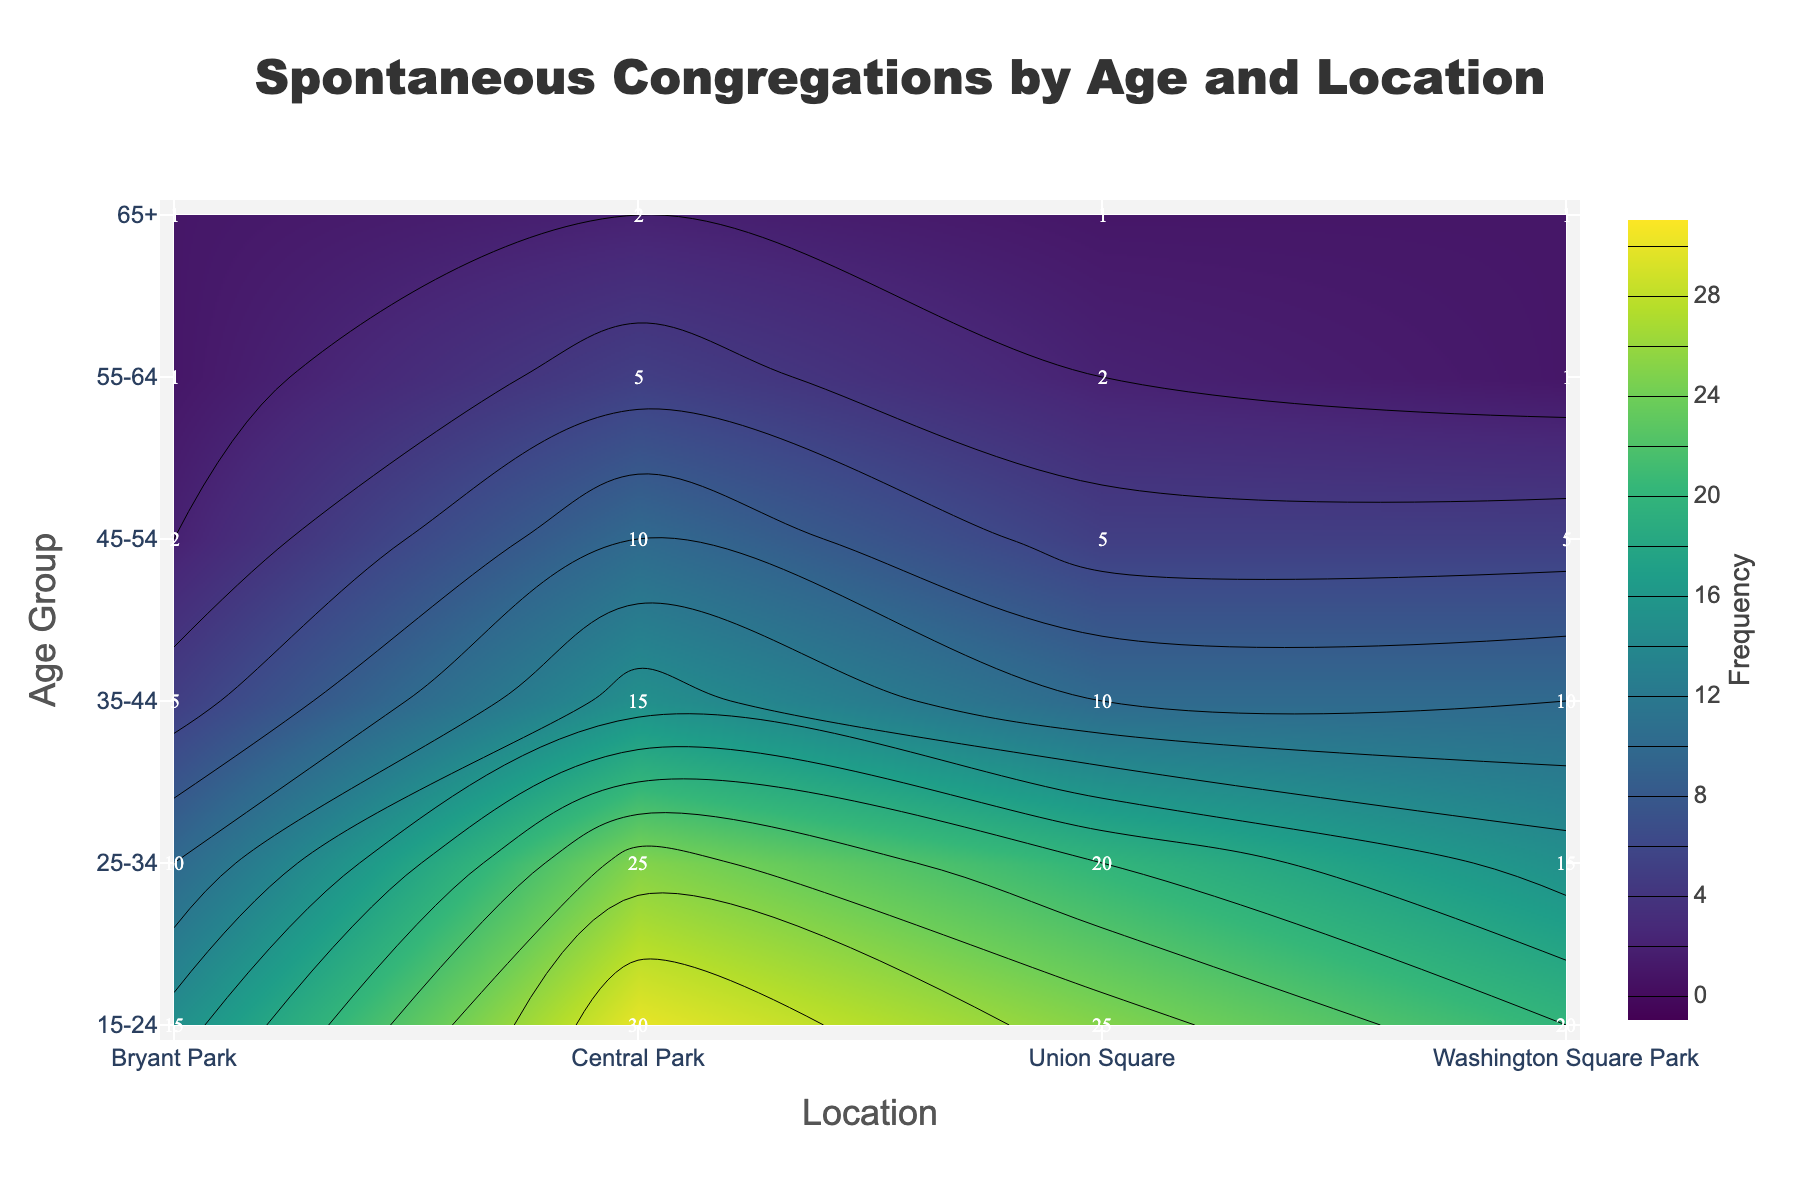What is the title of the figure? The title is located at the top center of the plot and reads 'Spontaneous Congregations by Age and Location'.
Answer: Spontaneous Congregations by Age and Location What are the axis labels? The labels for the x and y axes are 'Location' for the x-axis and 'Age Group' for the y-axis.
Answer: Location (x-axis), Age Group (y-axis) Which location has the highest frequency for the 15-24 age group? Looking at the contour plot, in the row labeled '15-24', Central Park has the highest frequency of 30.
Answer: Central Park What is the total frequency of spontaneous congregations for the age group 25-34? Sum the frequencies for the age group 25-34 across all locations: 25 (Central Park) + 20 (Union Square) + 15 (Washington Square Park) + 10 (Bryant Park) = 70.
Answer: 70 Which age group has the lowest frequency at Washington Square Park? On the 'Washington Square Park' column, the 55-64 and 65+ age groups both have the lowest frequency of 1.
Answer: 55-64 and 65+ What is the average frequency at Union Square for all age groups? Sum the frequencies for all age groups at Union Square: 25 (15-24) + 20 (25-34) + 10 (35-44) + 5 (45-54) + 2 (55-64) + 1 (65+). The total is 63, and there are 6 age groups, so the average is 63/6 = 10.5.
Answer: 10.5 Which age group shows the steepest decline in frequency from Central Park to Bryant Park? Compare the frequency decline for all age groups from Central Park to Bryant Park: 15-24 drops by 30-15=15, 25-34 drops by 25-10=15, 35-44 drops by 15-5=10, 45-54 drops by 10-2=8, 55-64 drops by 5-1=4, 65+ drops by 2-1=1. The 15-24 and 25-34 age groups both have drops of 15, showing the steepest decline.
Answer: 15-24 and 25-34 Is there any location where the 35-44 age group has the highest frequency? In comparing the '35-44' row across all locations, the frequency values are 15 (Central Park), 10 (Union Square), 10 (Washington Square Park), and 5 (Bryant Park), none of which are the highest compared to other age groups for those locations.
Answer: No How does the frequency trend change across age groups at Central Park? At Central Park, the frequency decreases with age: 30 (15-24), 25 (25-34), 15 (35-44), 10 (45-54), 5 (55-64), 2 (65+).
Answer: Decreases with age 